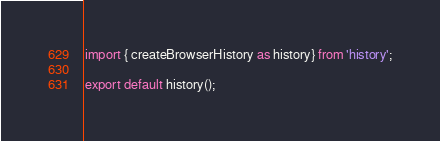<code> <loc_0><loc_0><loc_500><loc_500><_JavaScript_>
import { createBrowserHistory as history} from 'history';

export default history();</code> 